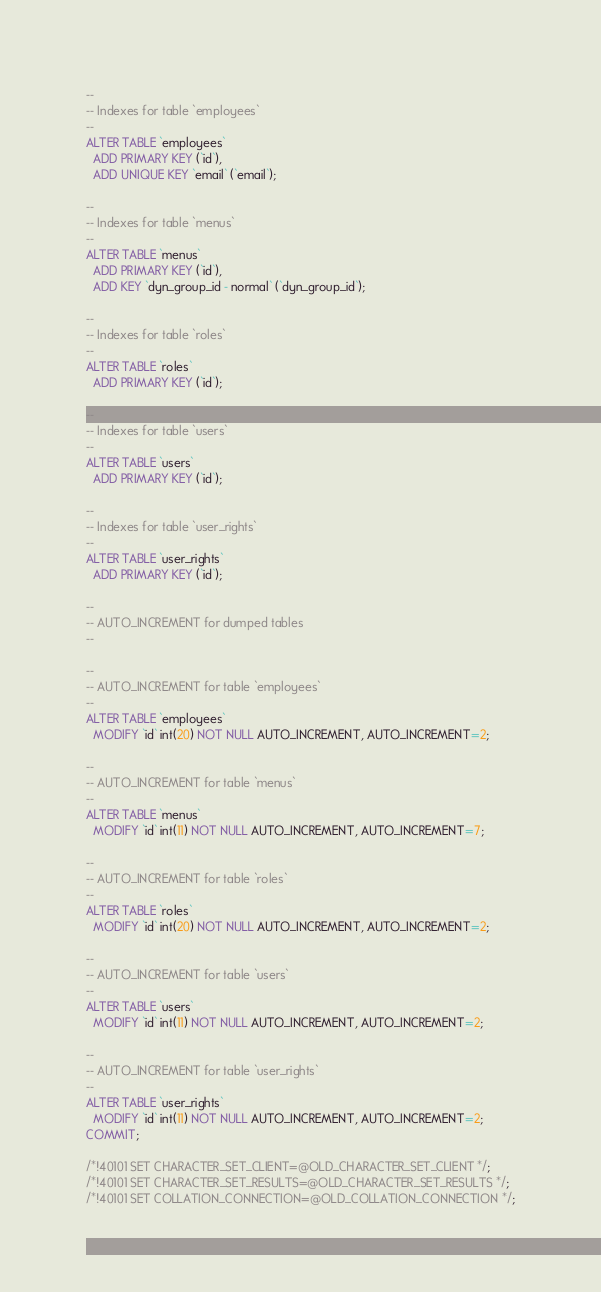Convert code to text. <code><loc_0><loc_0><loc_500><loc_500><_SQL_>--
-- Indexes for table `employees`
--
ALTER TABLE `employees`
  ADD PRIMARY KEY (`id`),
  ADD UNIQUE KEY `email` (`email`);

--
-- Indexes for table `menus`
--
ALTER TABLE `menus`
  ADD PRIMARY KEY (`id`),
  ADD KEY `dyn_group_id - normal` (`dyn_group_id`);

--
-- Indexes for table `roles`
--
ALTER TABLE `roles`
  ADD PRIMARY KEY (`id`);

--
-- Indexes for table `users`
--
ALTER TABLE `users`
  ADD PRIMARY KEY (`id`);

--
-- Indexes for table `user_rights`
--
ALTER TABLE `user_rights`
  ADD PRIMARY KEY (`id`);

--
-- AUTO_INCREMENT for dumped tables
--

--
-- AUTO_INCREMENT for table `employees`
--
ALTER TABLE `employees`
  MODIFY `id` int(20) NOT NULL AUTO_INCREMENT, AUTO_INCREMENT=2;

--
-- AUTO_INCREMENT for table `menus`
--
ALTER TABLE `menus`
  MODIFY `id` int(11) NOT NULL AUTO_INCREMENT, AUTO_INCREMENT=7;

--
-- AUTO_INCREMENT for table `roles`
--
ALTER TABLE `roles`
  MODIFY `id` int(20) NOT NULL AUTO_INCREMENT, AUTO_INCREMENT=2;

--
-- AUTO_INCREMENT for table `users`
--
ALTER TABLE `users`
  MODIFY `id` int(11) NOT NULL AUTO_INCREMENT, AUTO_INCREMENT=2;

--
-- AUTO_INCREMENT for table `user_rights`
--
ALTER TABLE `user_rights`
  MODIFY `id` int(11) NOT NULL AUTO_INCREMENT, AUTO_INCREMENT=2;
COMMIT;

/*!40101 SET CHARACTER_SET_CLIENT=@OLD_CHARACTER_SET_CLIENT */;
/*!40101 SET CHARACTER_SET_RESULTS=@OLD_CHARACTER_SET_RESULTS */;
/*!40101 SET COLLATION_CONNECTION=@OLD_COLLATION_CONNECTION */;
</code> 